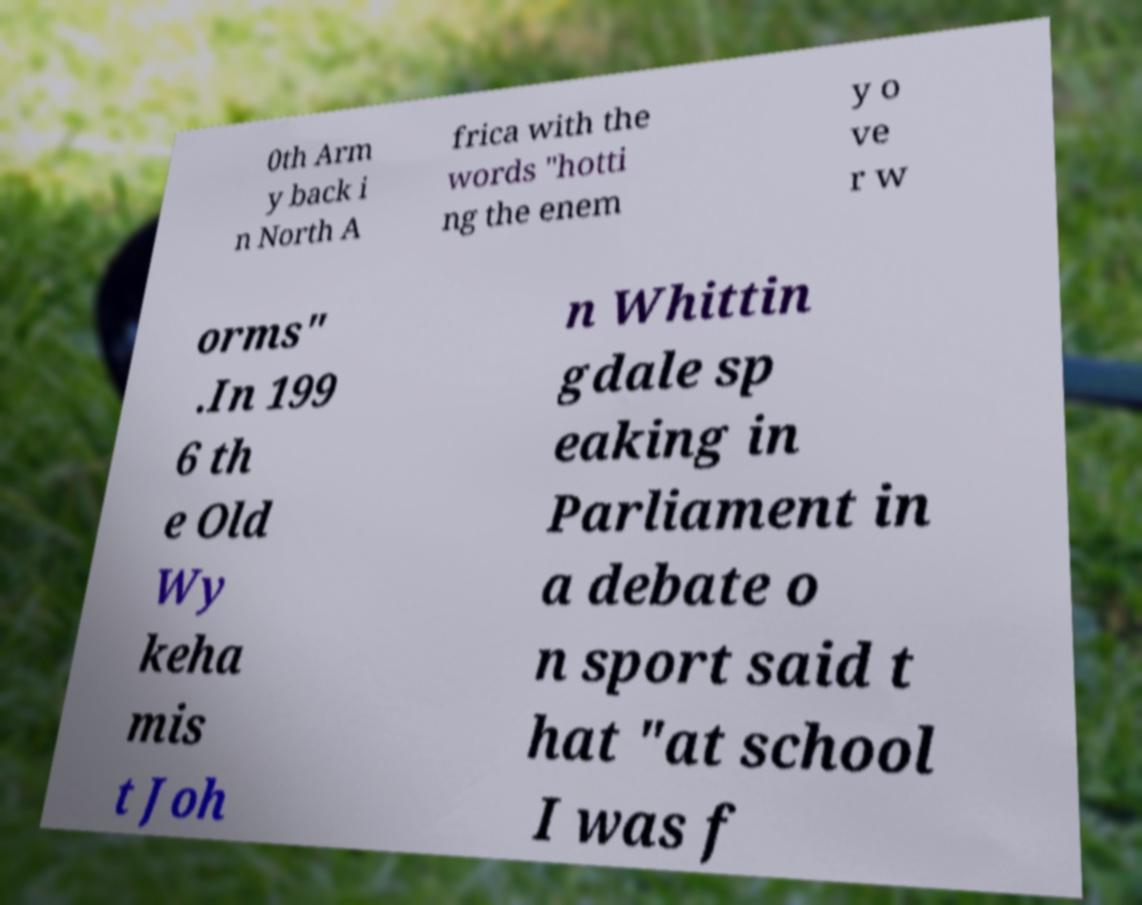Please identify and transcribe the text found in this image. 0th Arm y back i n North A frica with the words "hotti ng the enem y o ve r w orms" .In 199 6 th e Old Wy keha mis t Joh n Whittin gdale sp eaking in Parliament in a debate o n sport said t hat "at school I was f 